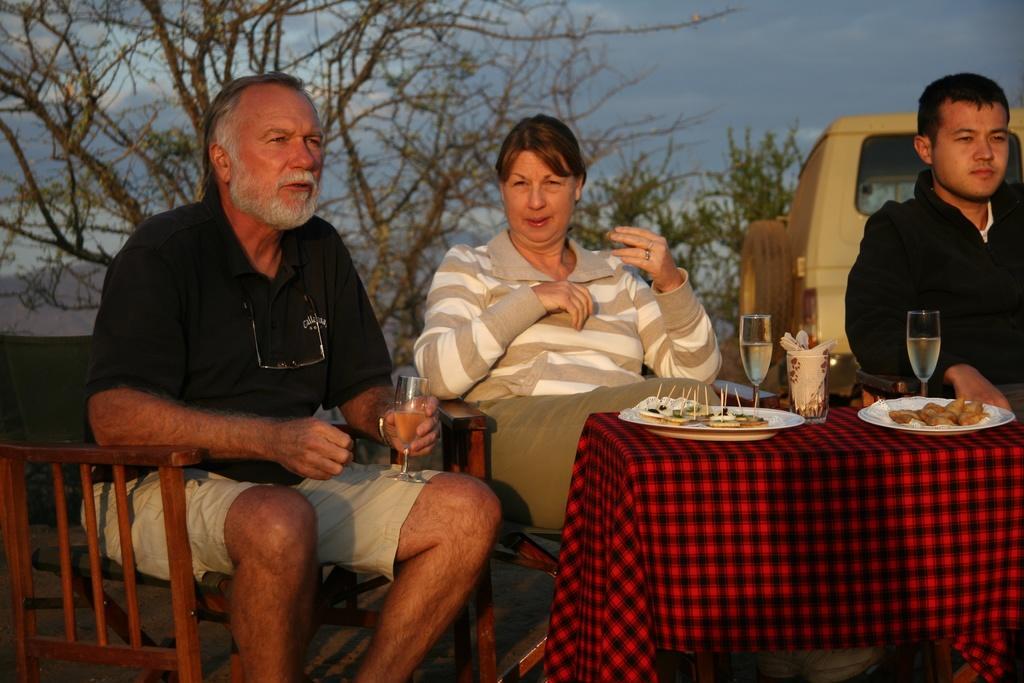In one or two sentences, can you explain what this image depicts? In the image there are three persons sitting on chair. The person in the left wearing black t-shirt is holding a wine glass. In the middle a lady is sitting. In the right a man wearing black jacket is sitting. In front of them there is a table on the table there are two wine glasses, tissues, foods on plate. In the background there are trees. 